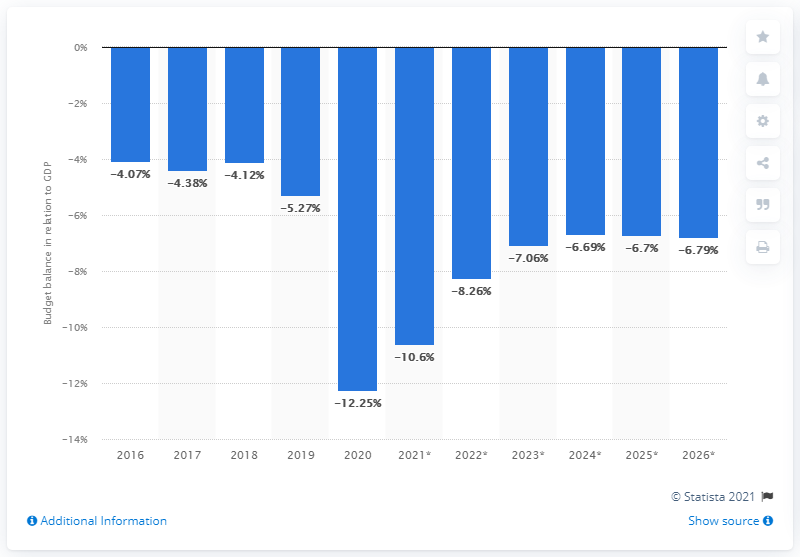Point out several critical features in this image. South Africa's budget balance, as a percentage of GDP, is shown for the years 2016 and 2020 in the given chart. 